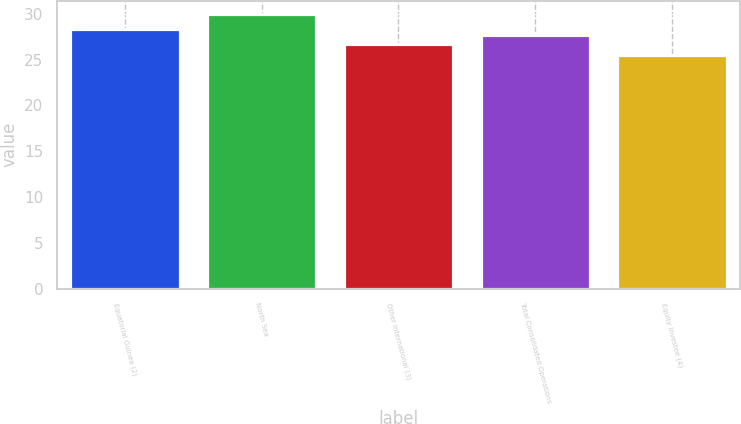Convert chart. <chart><loc_0><loc_0><loc_500><loc_500><bar_chart><fcel>Equatorial Guinea (2)<fcel>North Sea<fcel>Other International (3)<fcel>Total Consolidated Operations<fcel>Equity Investee (4)<nl><fcel>28.34<fcel>29.95<fcel>26.67<fcel>27.67<fcel>25.47<nl></chart> 